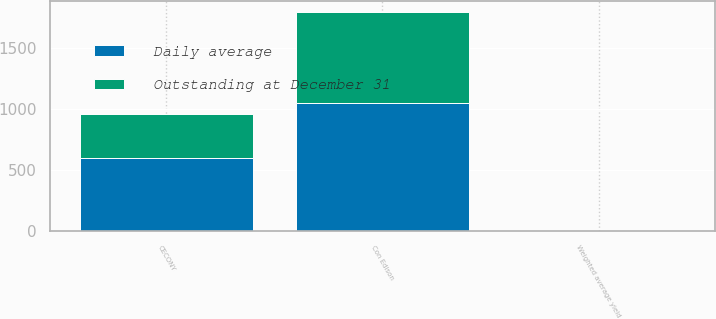Convert chart. <chart><loc_0><loc_0><loc_500><loc_500><stacked_bar_chart><ecel><fcel>Con Edison<fcel>CECONY<fcel>Weighted average yield<nl><fcel>Daily average<fcel>1054<fcel>600<fcel>1<nl><fcel>Outstanding at December 31<fcel>744<fcel>362<fcel>0.6<nl></chart> 